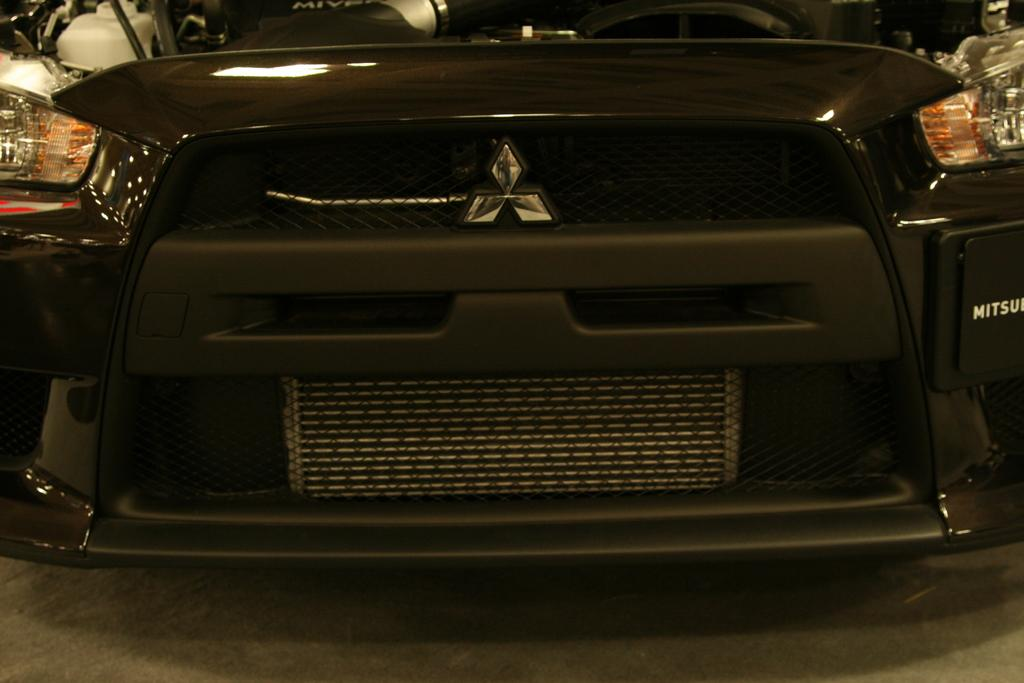What is located in the foreground of the image? In the foreground of the image, there is a bumper, headlights, and a bonnet. Can you describe the bottom part of the image? The bottom of the image appears to be a floor. What type of net can be seen hanging from the bumper in the image? There is no net present in the image, and the bumper is not connected to any net. 